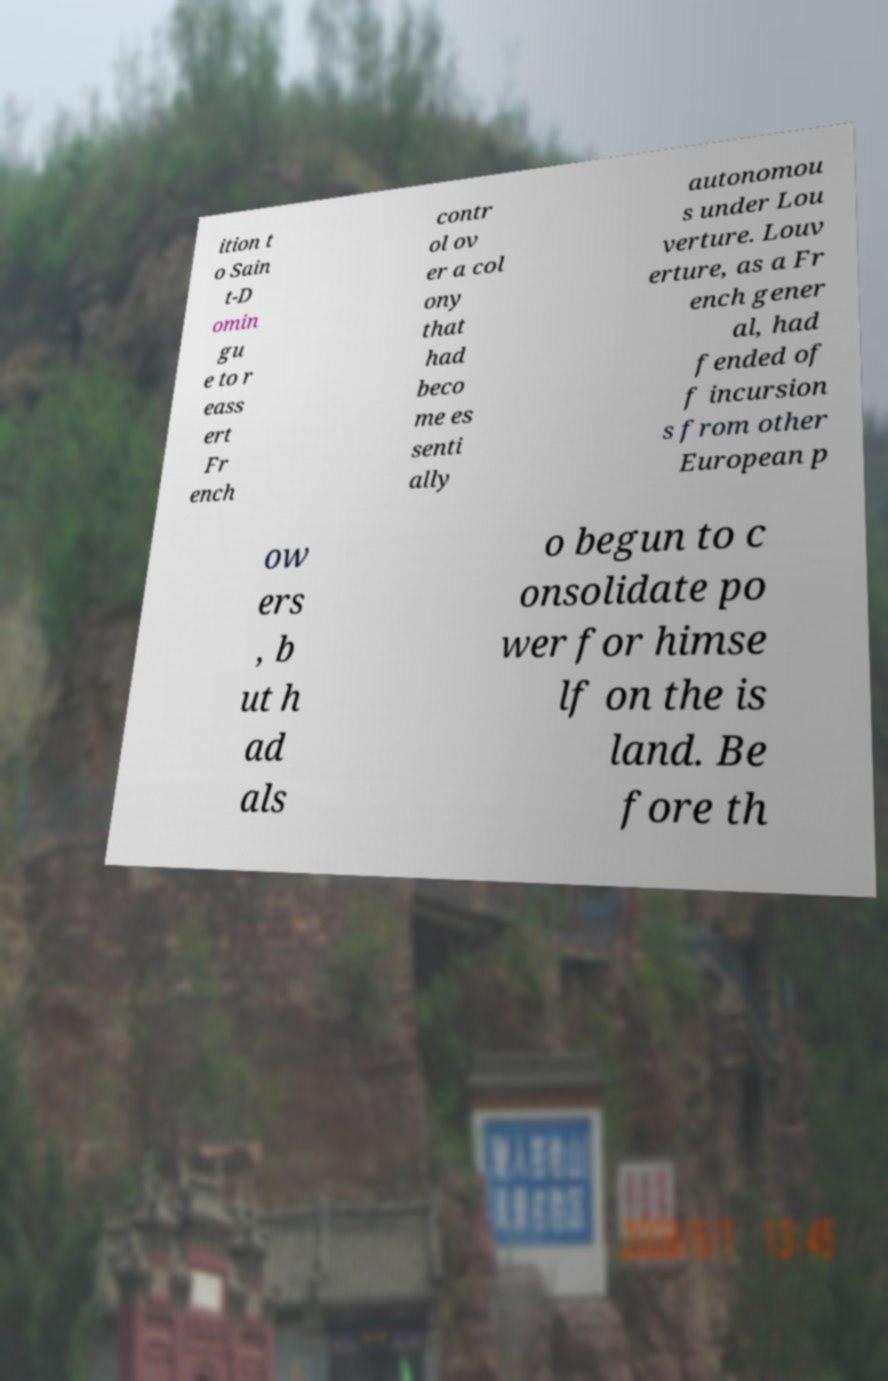There's text embedded in this image that I need extracted. Can you transcribe it verbatim? ition t o Sain t-D omin gu e to r eass ert Fr ench contr ol ov er a col ony that had beco me es senti ally autonomou s under Lou verture. Louv erture, as a Fr ench gener al, had fended of f incursion s from other European p ow ers , b ut h ad als o begun to c onsolidate po wer for himse lf on the is land. Be fore th 